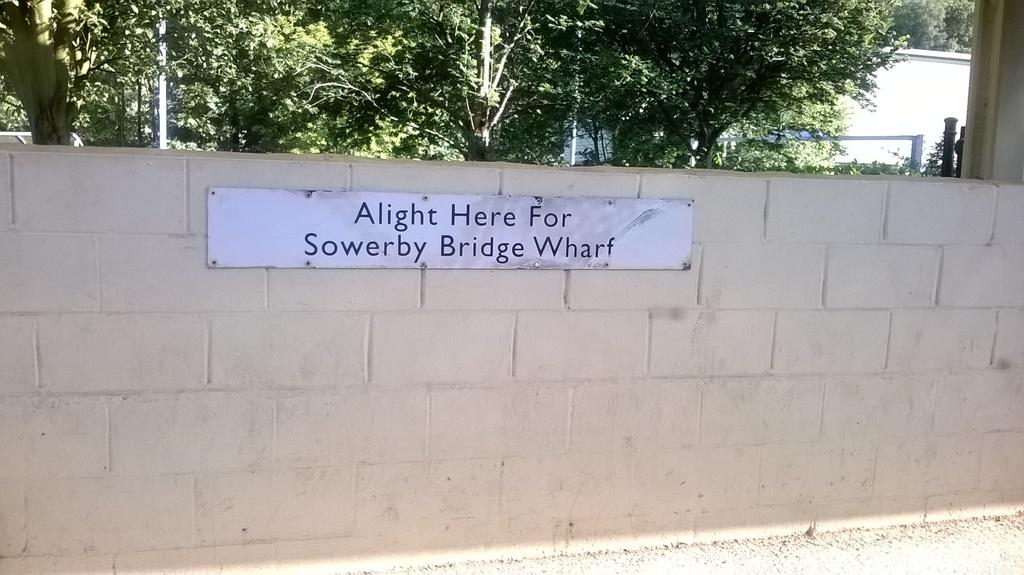What is the main object in the image? There is a white color board in the image. How is the white color board positioned in the image? The white color board is attached to the wall. What can be seen in the background of the image? There are trees in the background of the image. What is the color of the trees in the image? The trees are green in color. What type of development is taking place in the image? There is no development or construction activity visible in the image; it primarily features a white color board and green trees in the background. 